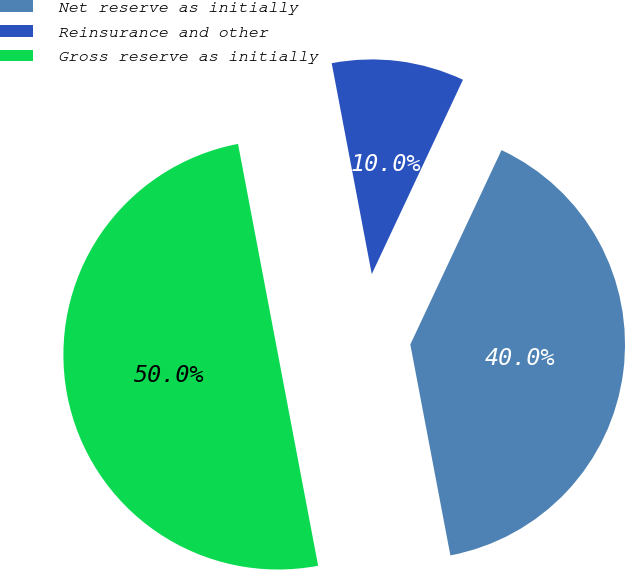Convert chart. <chart><loc_0><loc_0><loc_500><loc_500><pie_chart><fcel>Net reserve as initially<fcel>Reinsurance and other<fcel>Gross reserve as initially<nl><fcel>40.03%<fcel>9.97%<fcel>50.0%<nl></chart> 